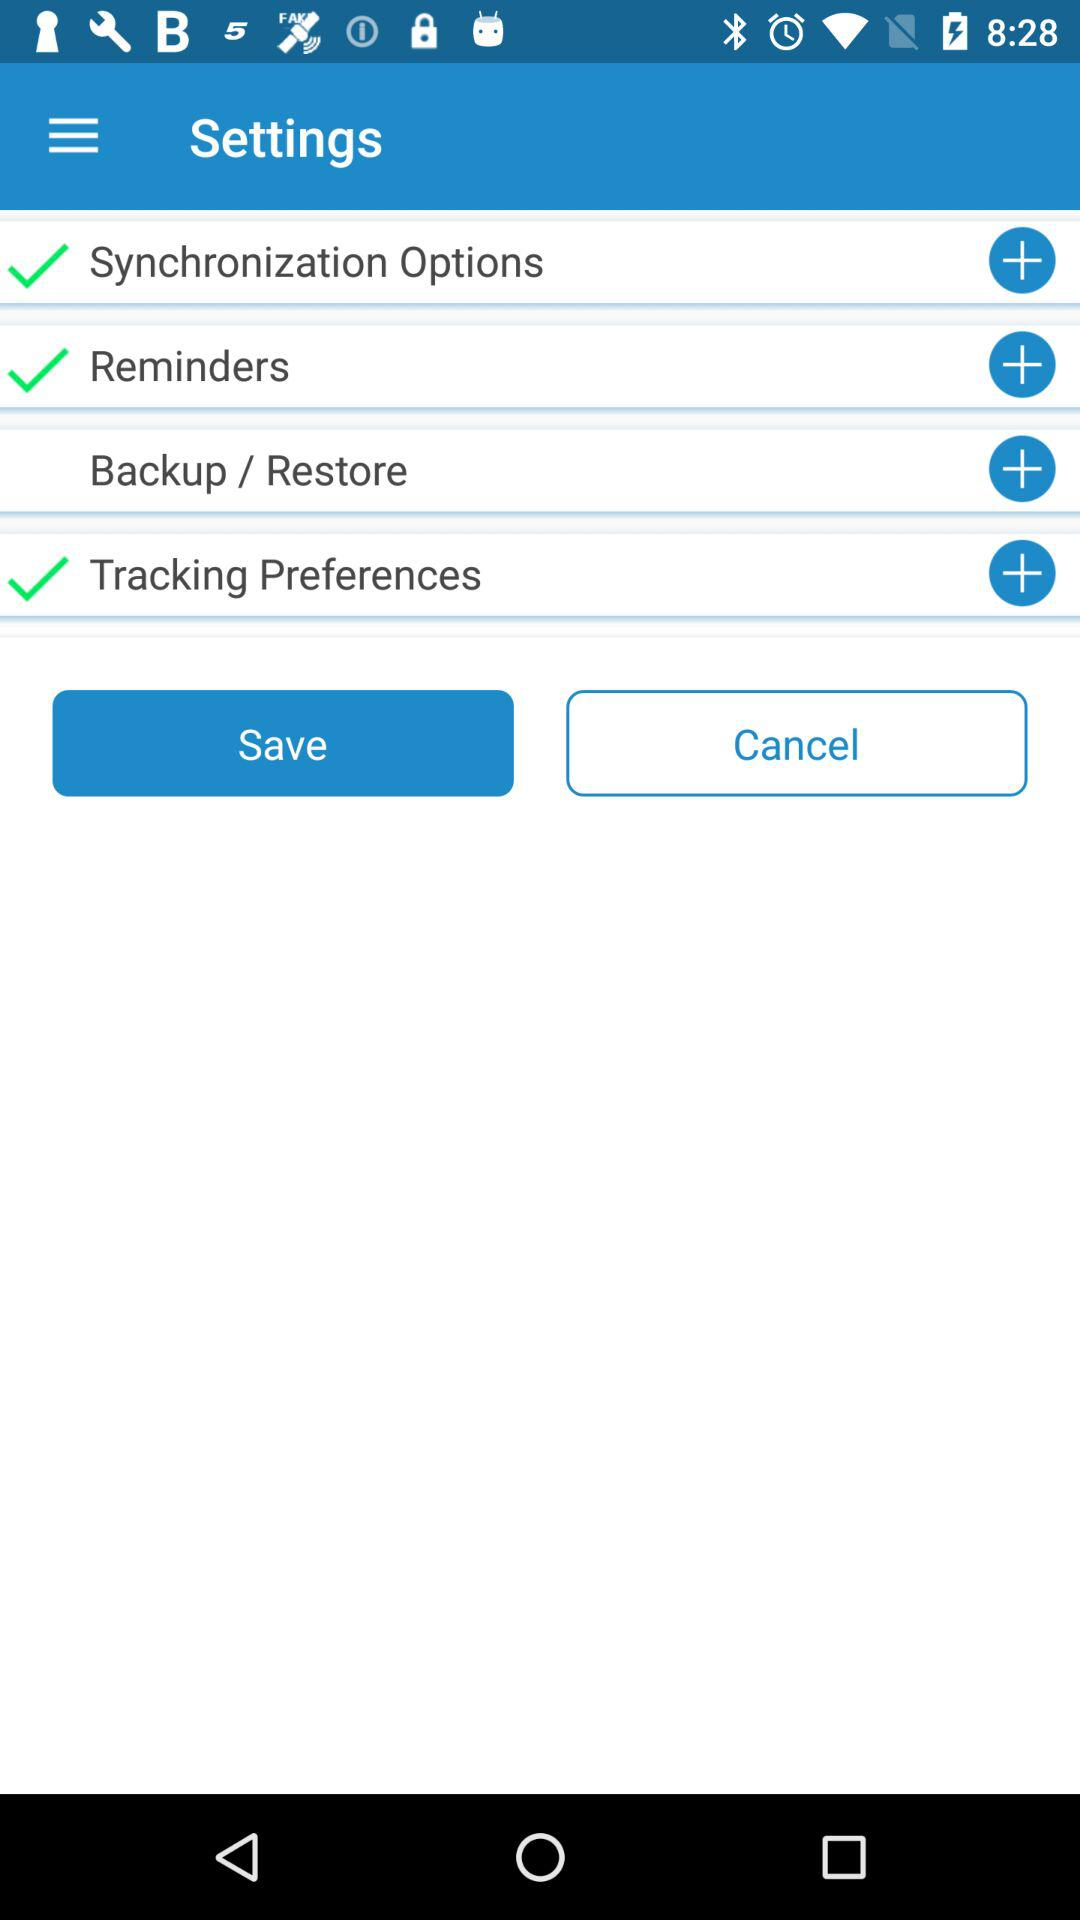How many items have a check mark?
Answer the question using a single word or phrase. 3 